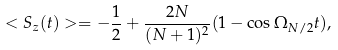<formula> <loc_0><loc_0><loc_500><loc_500>< S _ { z } ( t ) > = - \frac { 1 } { 2 } + \frac { 2 N } { ( N + 1 ) ^ { 2 } } ( 1 - \cos \Omega _ { N / 2 } t ) ,</formula> 